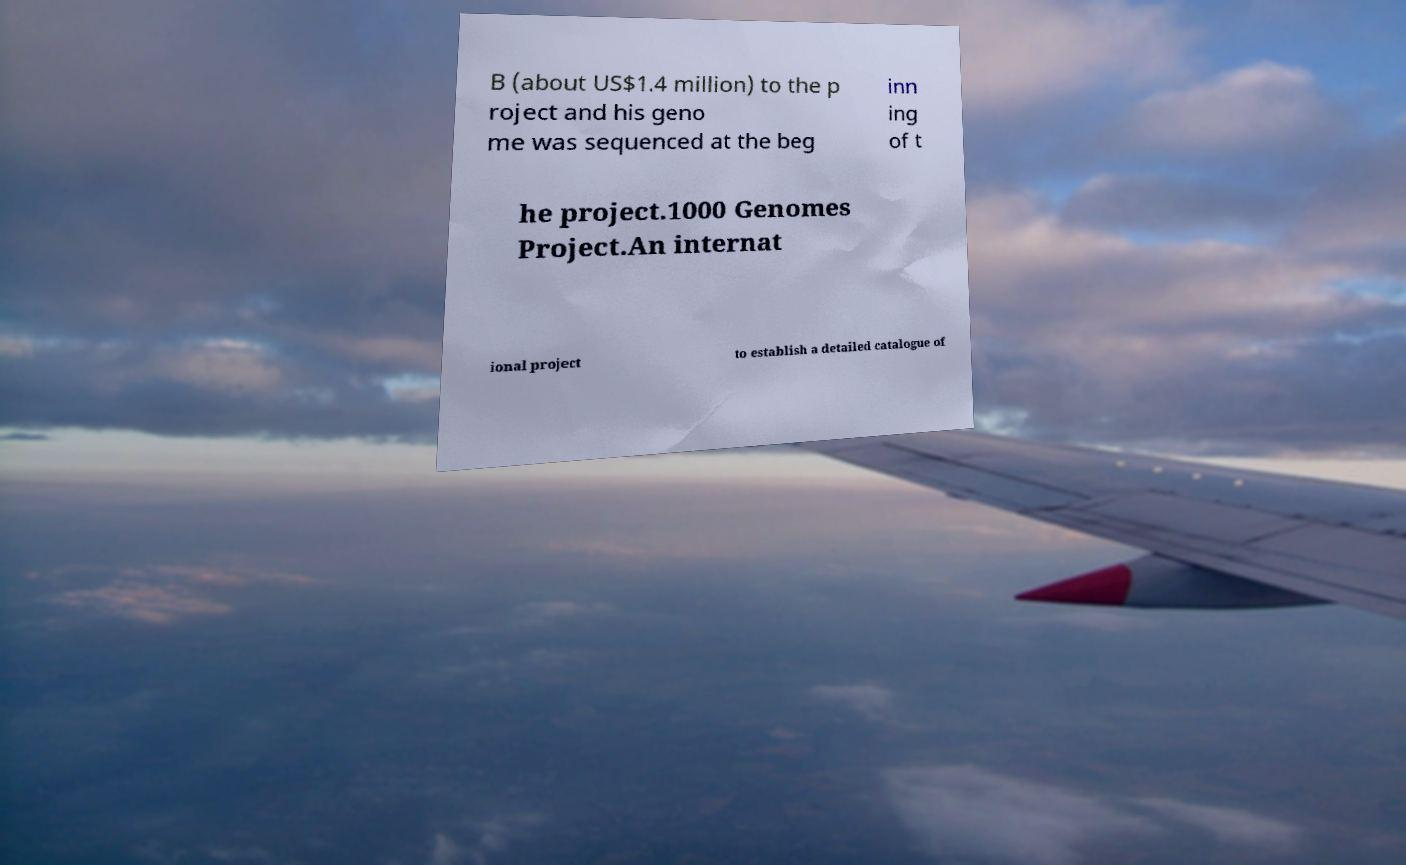There's text embedded in this image that I need extracted. Can you transcribe it verbatim? B (about US$1.4 million) to the p roject and his geno me was sequenced at the beg inn ing of t he project.1000 Genomes Project.An internat ional project to establish a detailed catalogue of 